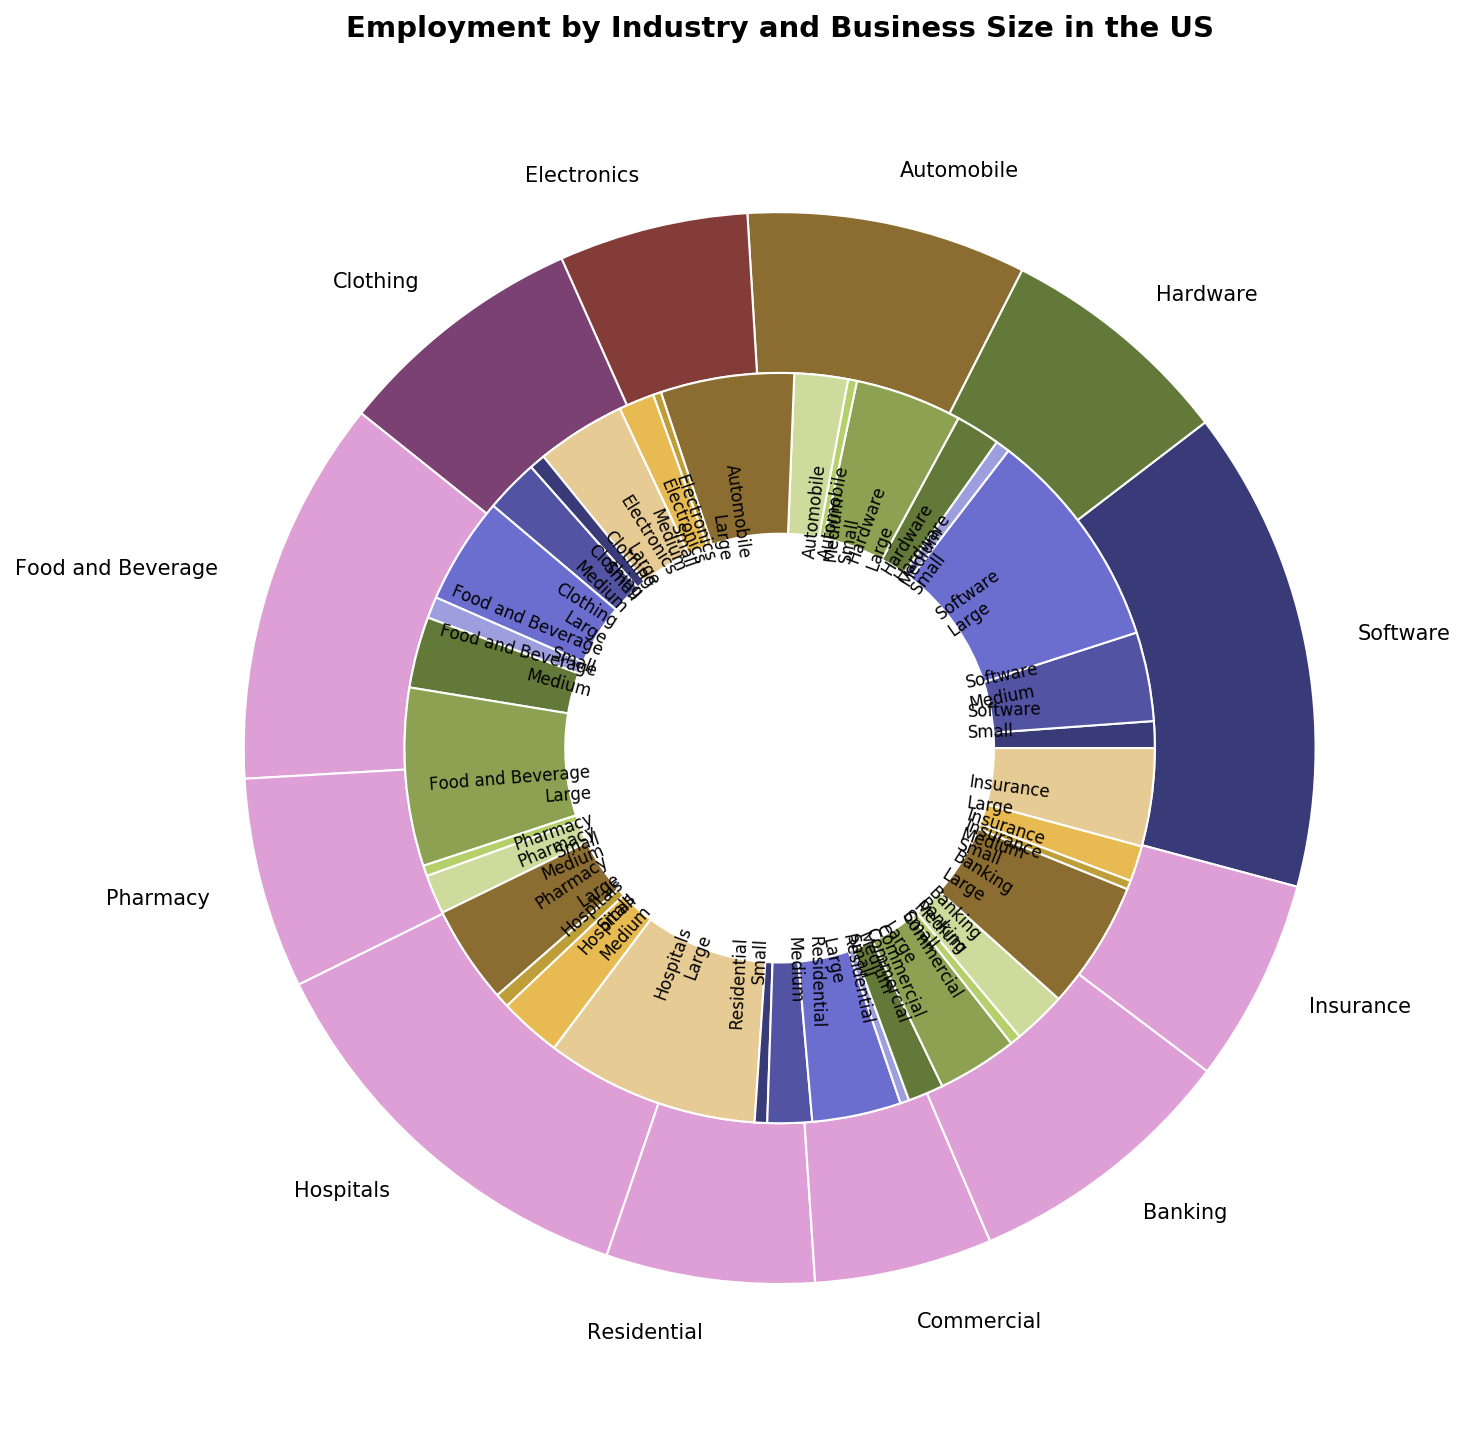Which sector has the highest employment? First, identify the outer sections representing different sectors. Then, compare the sizes (or angles) of these outer sections. "Healthcare" has the largest section, indicating it has the highest employment.
Answer: Healthcare Which has more employment, medium or large-sized businesses in the Retail sector? Focus on the inner sections associated with the Retail sector. Compare the size of the sections for medium and large-sized businesses. The section for large-sized businesses is larger than that for medium-sized businesses.
Answer: Large What is the total employment in the Construction sector? Add the employment numbers for each business size within the Construction sector: 70,000 (Residential, Small) + 250,000 (Residential, Medium) + 500,000 (Residential, Large) + 50,000 (Commercial, Small) + 200,000 (Commercial, Medium) + 450,000 (Commercial, Large) = 1,520,000.
Answer: 1,520,000 Which sector has the smallest employment in small-sized businesses? Compare the inner sections labeled for “Small”-sized businesses in each sector. The "Manufacturing" sector has the smallest employment for small-sized businesses.
Answer: Manufacturing What is the difference in employment between hardware and software sectors in the Technology industry? Calculate the total employment in the hardware sector: 80,000 (Small) + 250,000 (Medium) + 600,000 (Large) = 930,000. Calculate the total employment in the software sector: 150,000 (Small) + 500,000 (Medium) + 1,250,000 (Large) = 1,900,000. The difference is 1,900,000 - 930,000 = 970,000.
Answer: 970,000 Which sector has the most evenly distributed employment among different business sizes? Check each sector and compare the inner sections representing small, medium, and large-sized businesses. "Finance" has roughly equal sections distributed among small, medium, and large-sized businesses.
Answer: Finance 